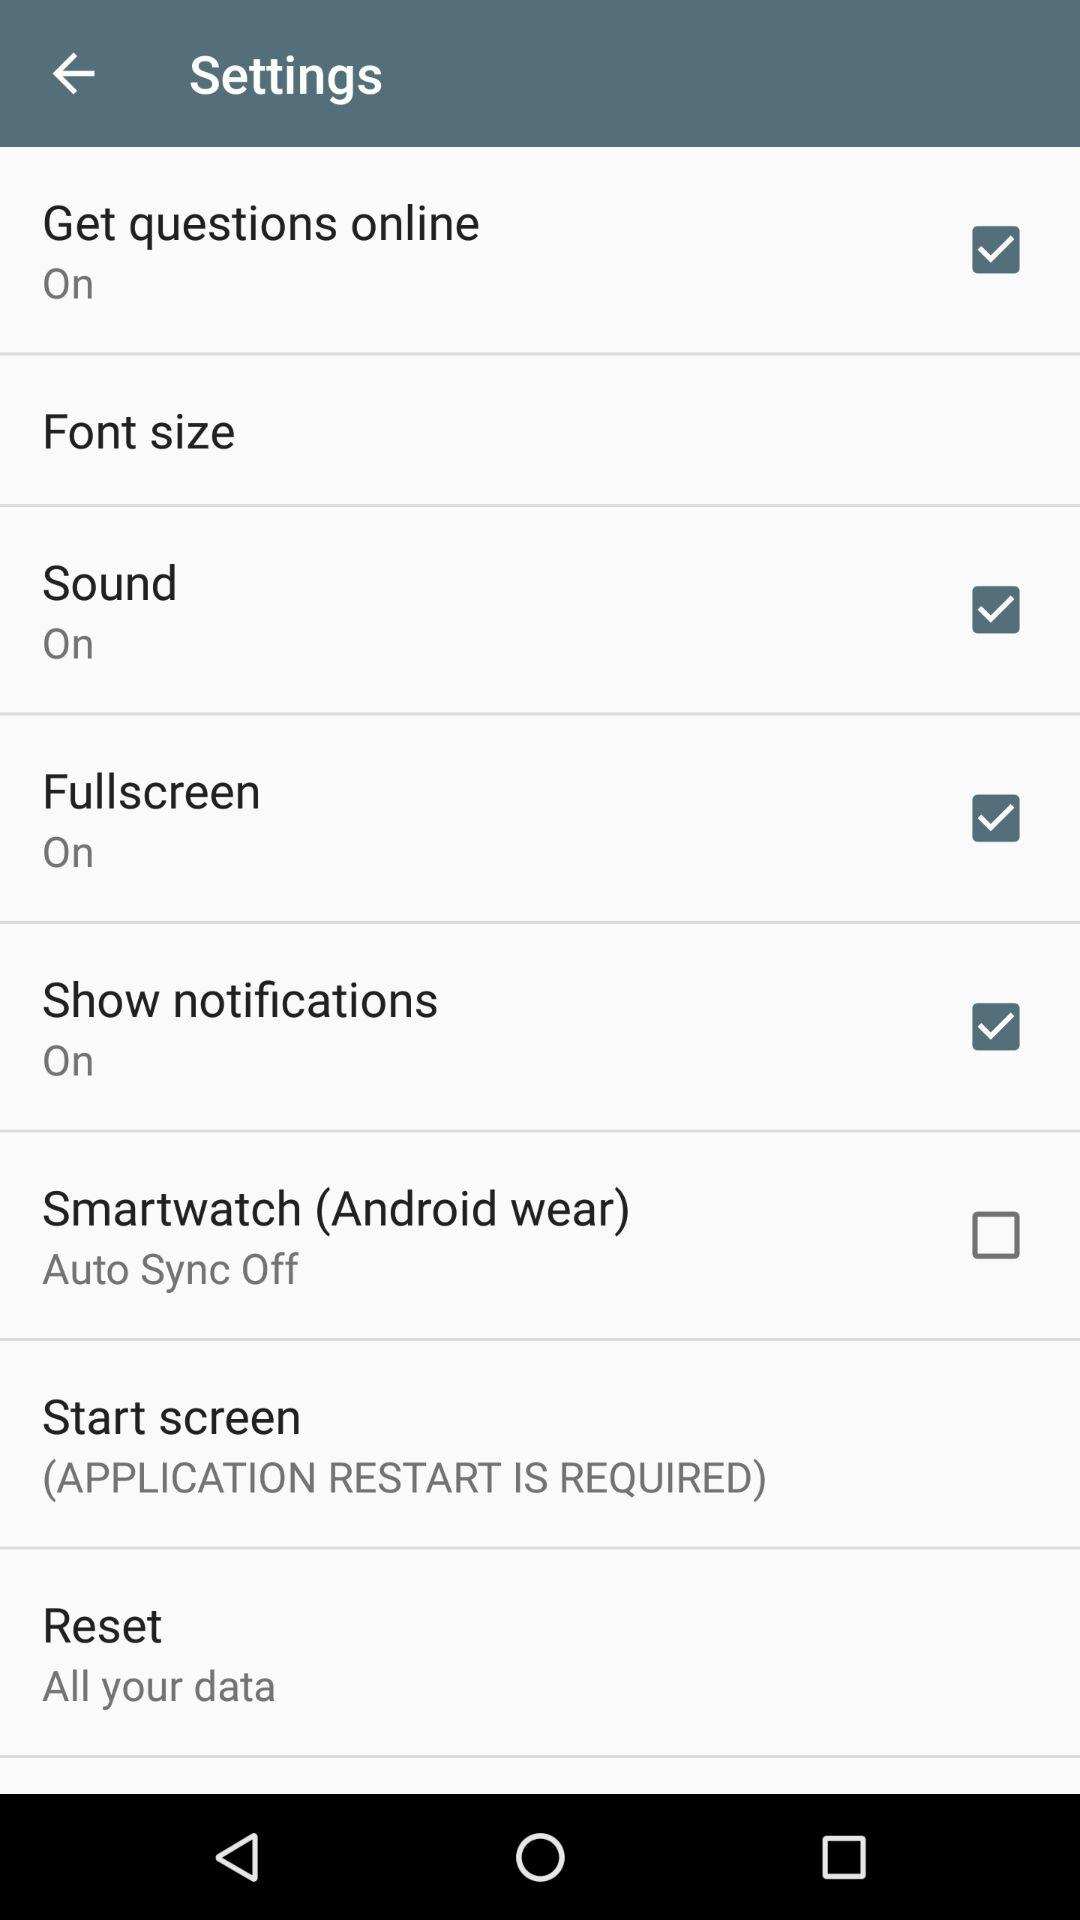Which options are selected? The selected options are "Get questions online", "Sound", "Fullscreen", "Show notifications". 